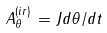<formula> <loc_0><loc_0><loc_500><loc_500>A _ { \theta } ^ { ( i r ) } \, = J d \theta / d t</formula> 